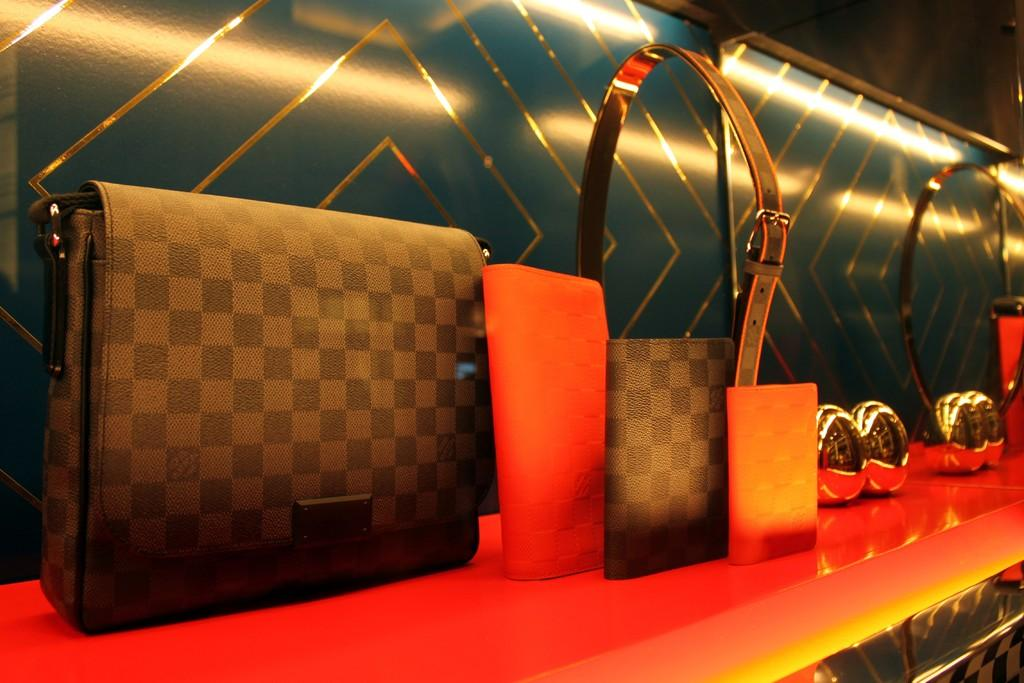What piece of furniture is present in the image? There is a table in the image. What items are placed on the table? There is a wallet, a handbag, and a belt on the table. How many giraffes can be seen in the image? There are no giraffes present in the image. What suggestion is being made by the boys in the image? There are no boys present in the image, so no suggestion can be made. 